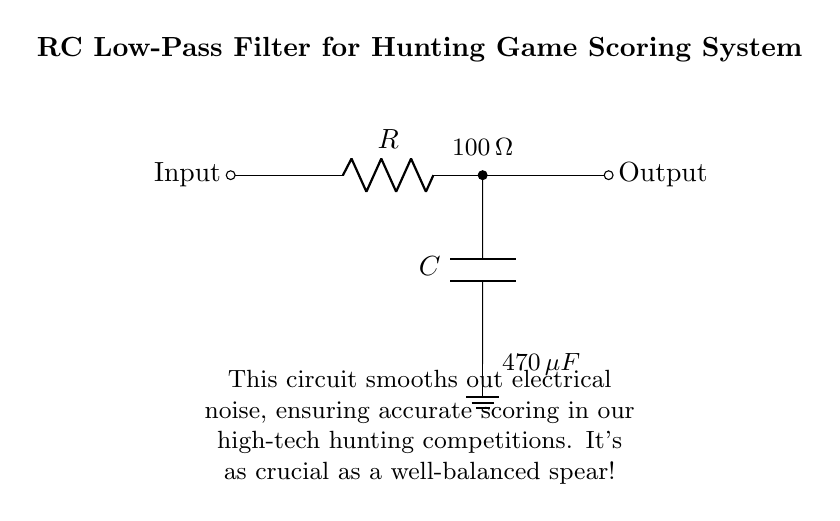What is the value of the resistor in this circuit? The value of the resistor is stated directly in the circuit diagram, where it is labeled with a value. It shows the resistor as 100 ohms.
Answer: 100 ohm What is the value of the capacitor in this circuit? The value of the capacitor is also labeled in the circuit diagram. It indicates that the capacitor has a value of 470 microfarads.
Answer: 470 microfarad What type of filter is represented in this circuit? The circuit is specifically designed as an RC low-pass filter, which is indicated in the title of the diagram and by the configuration of the components where the capacitor and resistor are connected.
Answer: Low-pass filter What does this circuit smooth out? The explanation provided in the diagram states that the purpose of the circuit is to smooth out electrical noise, which is important for accurate scoring in the hunting game system.
Answer: Electrical noise How does this configuration affect high frequencies? In an RC low-pass filter, high frequencies are attenuated because the capacitor offers a low impedance at higher frequencies, effectively shorting them to ground. This means that as frequency increases, the output voltage decreases significantly.
Answer: Attenuates high frequencies What is the purpose of this circuit in the hunting game scoring system? The explanation in the diagram specifies the circuit's purpose to ensure accurate scoring by filtering out unwanted electrical noise, which can interfere with the scoring mechanism.
Answer: Accurate scoring 